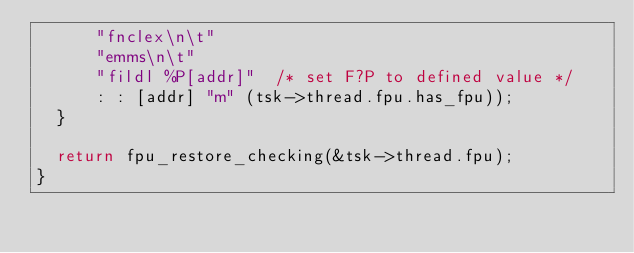Convert code to text. <code><loc_0><loc_0><loc_500><loc_500><_C_>			"fnclex\n\t"
			"emms\n\t"
			"fildl %P[addr]"	/* set F?P to defined value */
			: : [addr] "m" (tsk->thread.fpu.has_fpu));
	}

	return fpu_restore_checking(&tsk->thread.fpu);
}
</code> 